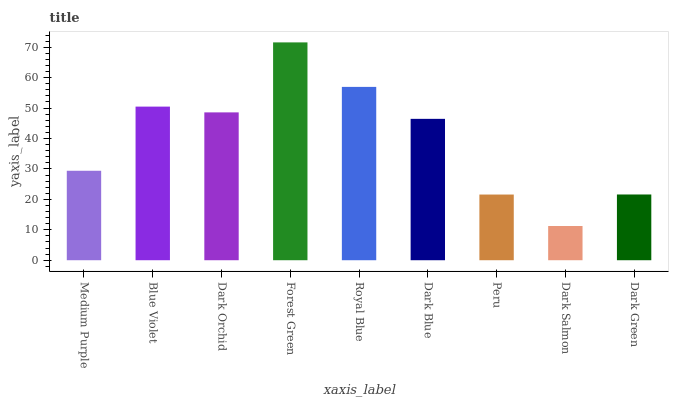Is Dark Salmon the minimum?
Answer yes or no. Yes. Is Forest Green the maximum?
Answer yes or no. Yes. Is Blue Violet the minimum?
Answer yes or no. No. Is Blue Violet the maximum?
Answer yes or no. No. Is Blue Violet greater than Medium Purple?
Answer yes or no. Yes. Is Medium Purple less than Blue Violet?
Answer yes or no. Yes. Is Medium Purple greater than Blue Violet?
Answer yes or no. No. Is Blue Violet less than Medium Purple?
Answer yes or no. No. Is Dark Blue the high median?
Answer yes or no. Yes. Is Dark Blue the low median?
Answer yes or no. Yes. Is Medium Purple the high median?
Answer yes or no. No. Is Medium Purple the low median?
Answer yes or no. No. 